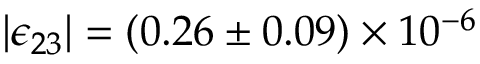Convert formula to latex. <formula><loc_0><loc_0><loc_500><loc_500>| \epsilon _ { 2 3 } | = ( 0 . 2 6 \pm 0 . 0 9 ) \times 1 0 ^ { - 6 }</formula> 